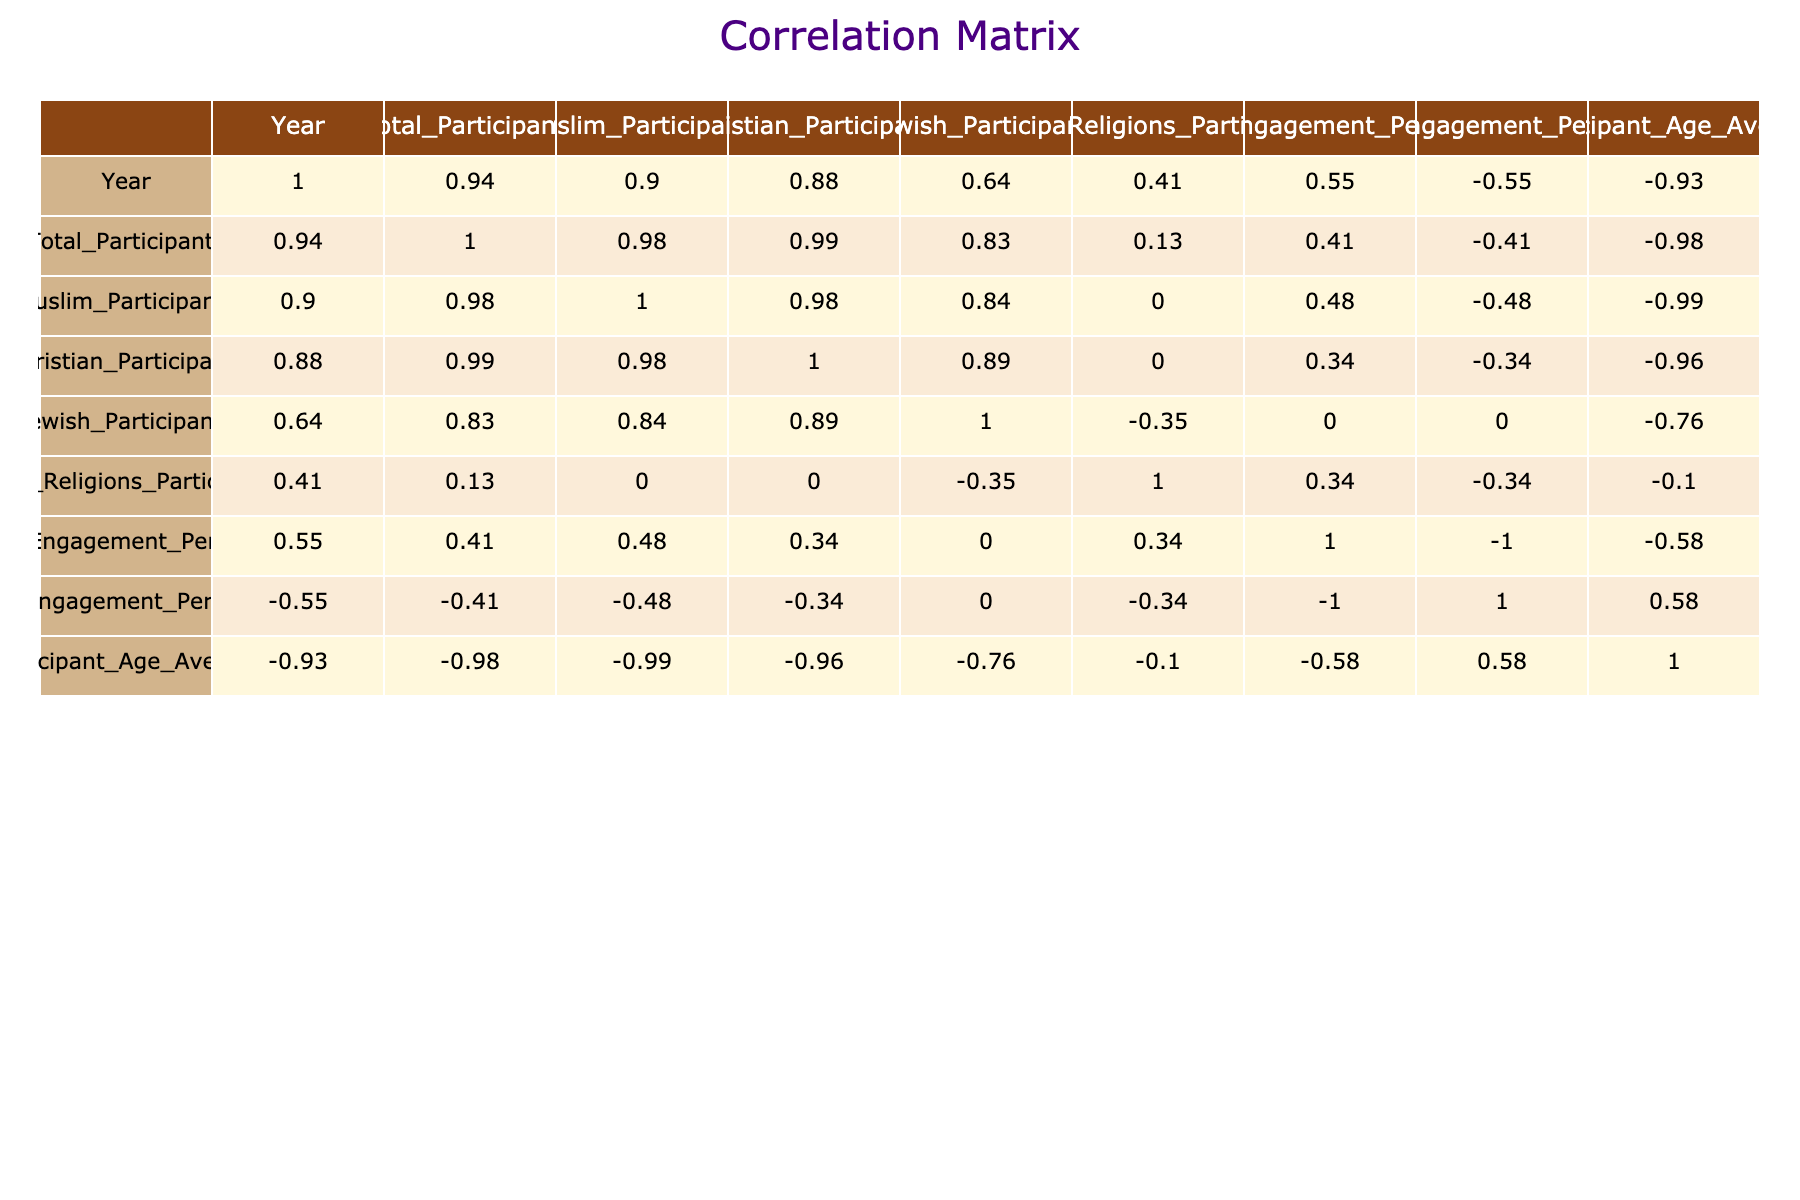What is the total number of participants in the "Faith Together" program? Looking at the "Faith Together" program in the table, the "Total_Participants" column for the year 2023 shows a value of 200.
Answer: 200 What percentage of rural engagement is highest among the programs? To find the highest rural engagement percentage, we compare the "Rural_Engagement_Percentage" values across all programs. The maximum value occurs in the "Unity in Diversity" program at 40%.
Answer: 40 How many more Muslim participants were there in the "Pathways to Peace" program compared to the "Bridges of Understanding" program? The "Pathways to Peace" program has 75 Muslim participants, while the "Bridges of Understanding" has 50. The difference is calculated as 75 - 50 = 25.
Answer: 25 True or False: The "Common Ground" program had a higher average participant age than the "Unity in Diversity" program. For "Common Ground," the average participant age is 32, while for "Unity in Diversity," it is 35. Since 32 is less than 35, the statement is false.
Answer: False What is the average number of Christian participants across all programs listed? To calculate the average, add the number of Christian participants: 50 (Bridges of Understanding) + 70 (Faith Together) + 60 (Common Ground) + 50 (Alliance for Harmony) + 55 (Pathways to Peace) + 40 (Unity in Diversity) = 325. Then divide by the number of programs, which is 6, giving us an average of 325 / 6 = approximately 54.17.
Answer: 54.17 Which program had the lowest participant average age and what was that age? By looking at the "Participant_Age_Average" column, "Faith Together" has the lowest average age at 30 years.
Answer: 30 How does the urban engagement percentage compare between the "Alliance for Harmony" and the "Bridges of Understanding" programs? The "Alliance for Harmony" program shows an urban engagement percentage of 50%, while the "Bridges of Understanding" shows 50% as well. Thus, they are equal in urban engagement percentage.
Answer: They are equal at 50% In which year was there greater total engagement, 2022 or 2023? To determine the total engagement in each year, we sum the "Total_Participants" for each year. In 2022: 150 (Unity in Diversity) + 160 (Pathways to Peace) = 310. In 2023: 200 (Faith Together) + 180 (Common Ground) = 380. Comparing, 380 is greater than 310.
Answer: 2023 had greater engagement 